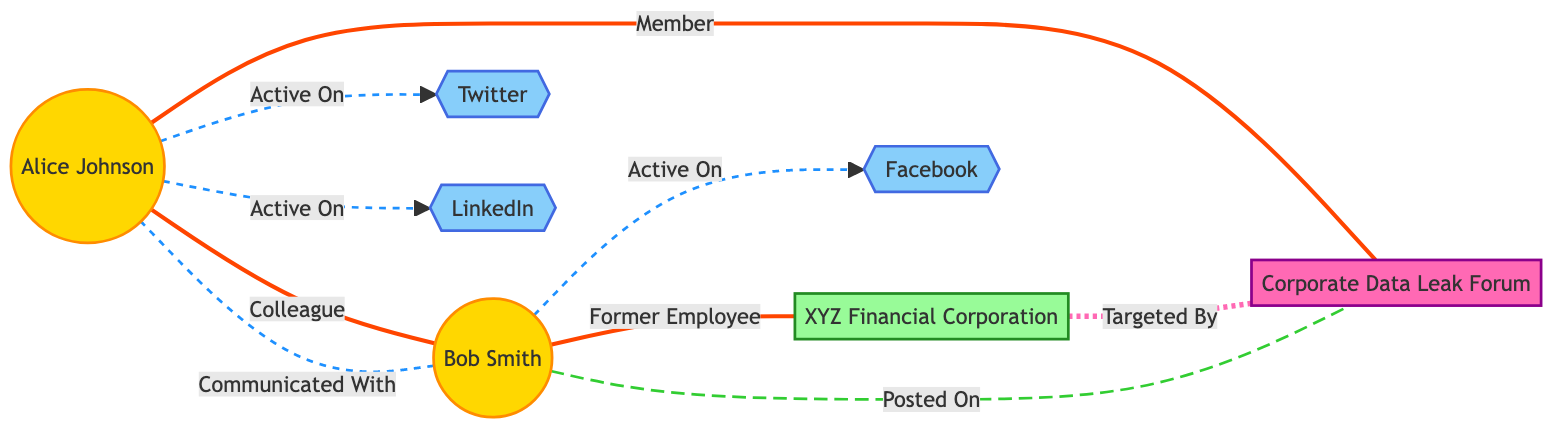What is the total number of nodes in the diagram? The nodes listed are: Alice Johnson, Bob Smith, XYZ Financial Corporation, Corporate Data Leak Forum, Twitter, Facebook, and LinkedIn. Counting these, there are 7 nodes in total.
Answer: 7 Who is Alice Johnson's colleague? In the diagram, Alice Johnson has a connection labeled "Colleague" with Bob Smith. This relationship is indicated by the edge connecting the two nodes.
Answer: Bob Smith On which social media platforms is Alice Johnson active? The diagram shows two interactions where Alice Johnson is labeled as "Active On," specifically with Twitter and LinkedIn. This means she uses both these social media platforms.
Answer: Twitter, LinkedIn What is the relationship between Bob Smith and XYZ Financial Corporation? The diagram indicates that Bob Smith, represented in the edge, has a relationship labeled "Former Employee" with XYZ Financial Corporation. This means he used to work for that organization.
Answer: Former Employee How many different social media platforms are represented in the diagram? The diagram shows three social media platforms: Twitter, Facebook, and LinkedIn. Thus, we can count a total of three distinct platforms.
Answer: 3 Which forum is connected to both Alice Johnson and XYZ Financial Corporation? Alice Johnson is connected to the Corporate Data Leak Forum with a relationship labeled "Member," and XYZ Financial Corporation is connected to the same forum indicating it was "Targeted By." This means the forum is related to both individuals.
Answer: Corporate Data Leak Forum What type of connection exists between Bob Smith and the Corporate Data Leak Forum? The diagram shows that Bob Smith has posted on the Corporate Data Leak Forum, indicated by the edge labeled "Posted On." This connection indicates his activity related to the forum.
Answer: Posted On Which person is involved in communicating with the other, based on the interactions? The interaction between Bob Smith and Alice Johnson is labeled "Communicated With," showing a direct communication line from Bob to Alice.
Answer: Alice Johnson 